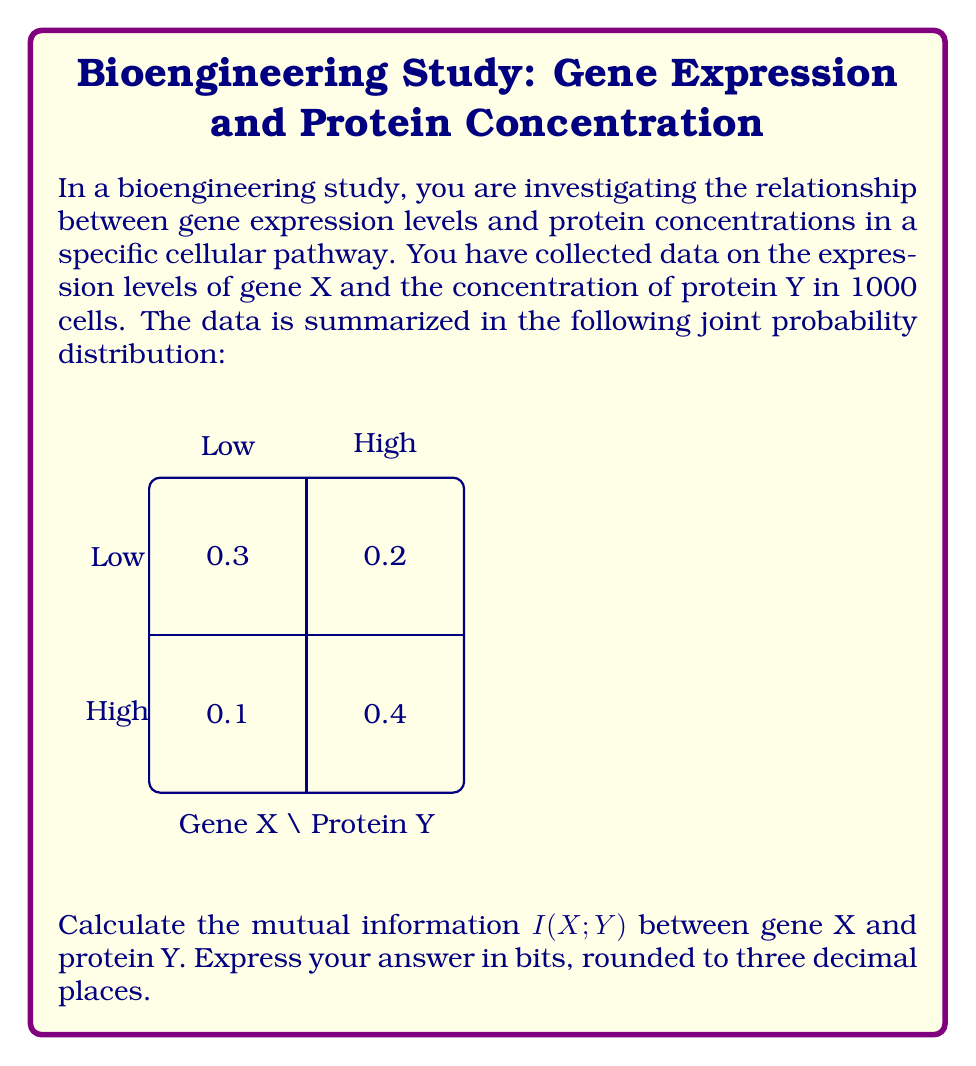Give your solution to this math problem. To calculate the mutual information $I(X;Y)$, we'll follow these steps:

1) First, we need to calculate the marginal probabilities:
   $P(X=\text{Low}) = 0.3 + 0.1 = 0.4$
   $P(X=\text{High}) = 0.2 + 0.4 = 0.6$
   $P(Y=\text{Low}) = 0.3 + 0.2 = 0.5$
   $P(Y=\text{High}) = 0.1 + 0.4 = 0.5$

2) The mutual information is defined as:
   $$I(X;Y) = \sum_{x}\sum_{y} P(x,y) \log_2 \frac{P(x,y)}{P(x)P(y)}$$

3) Let's calculate each term:
   For $X=\text{Low}, Y=\text{Low}$: $0.3 \log_2 \frac{0.3}{0.4 \cdot 0.5} = 0.3 \log_2 1.5 = 0.1368$
   For $X=\text{Low}, Y=\text{High}$: $0.1 \log_2 \frac{0.1}{0.4 \cdot 0.5} = 0.1 \log_2 0.5 = -0.1$
   For $X=\text{High}, Y=\text{Low}$: $0.2 \log_2 \frac{0.2}{0.6 \cdot 0.5} = 0.2 \log_2 \frac{2}{3} = -0.0899$
   For $X=\text{High}, Y=\text{High}$: $0.4 \log_2 \frac{0.4}{0.6 \cdot 0.5} = 0.4 \log_2 \frac{4}{3} = 0.1510$

4) Sum all these terms:
   $I(X;Y) = 0.1368 - 0.1 - 0.0899 + 0.1510 = 0.0979$ bits

5) Rounding to three decimal places:
   $I(X;Y) \approx 0.098$ bits
Answer: 0.098 bits 